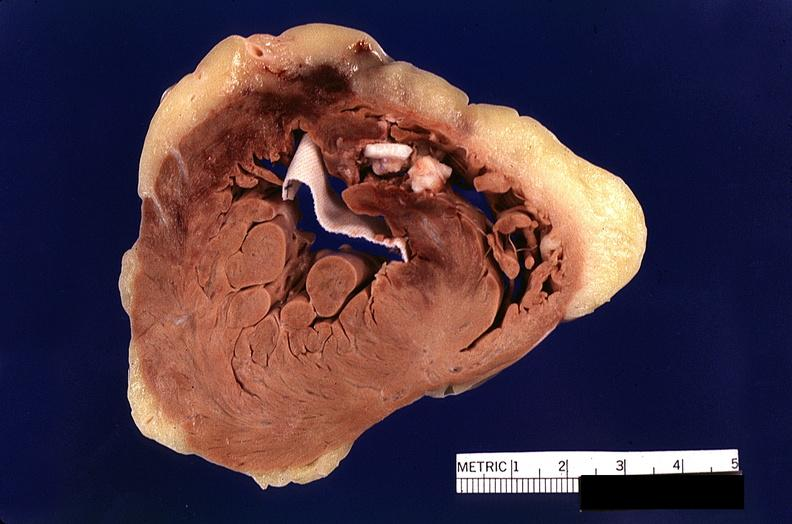where is this?
Answer the question using a single word or phrase. Heart 